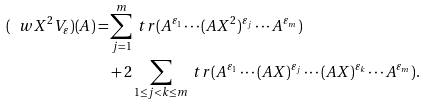Convert formula to latex. <formula><loc_0><loc_0><loc_500><loc_500>( \ w X ^ { 2 } V _ { \varepsilon } ) ( A ) = & \sum _ { j = 1 } ^ { m } \ t r ( A ^ { \varepsilon _ { 1 } } \cdots ( A X ^ { 2 } ) ^ { \varepsilon _ { j } } \cdots A ^ { \varepsilon _ { m } } ) \\ & + 2 \sum _ { 1 \leq j < k \leq m } \ t r ( A ^ { \varepsilon _ { 1 } } \cdots ( A X ) ^ { \varepsilon _ { j } } \cdots ( A X ) ^ { \varepsilon _ { k } } \cdots A ^ { \varepsilon _ { m } } ) .</formula> 